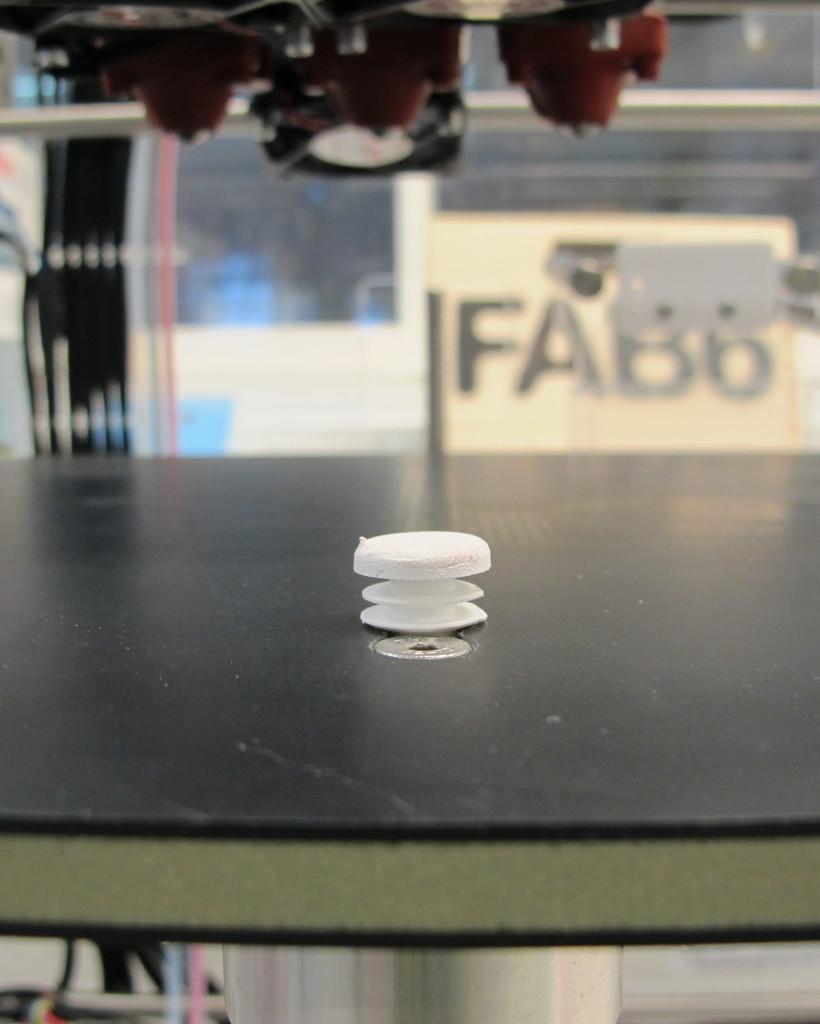Please provide a concise description of this image. In this image on a table there is a plastic screw. In the background there is a glass wall. On the top on the ceiling there are lights. 